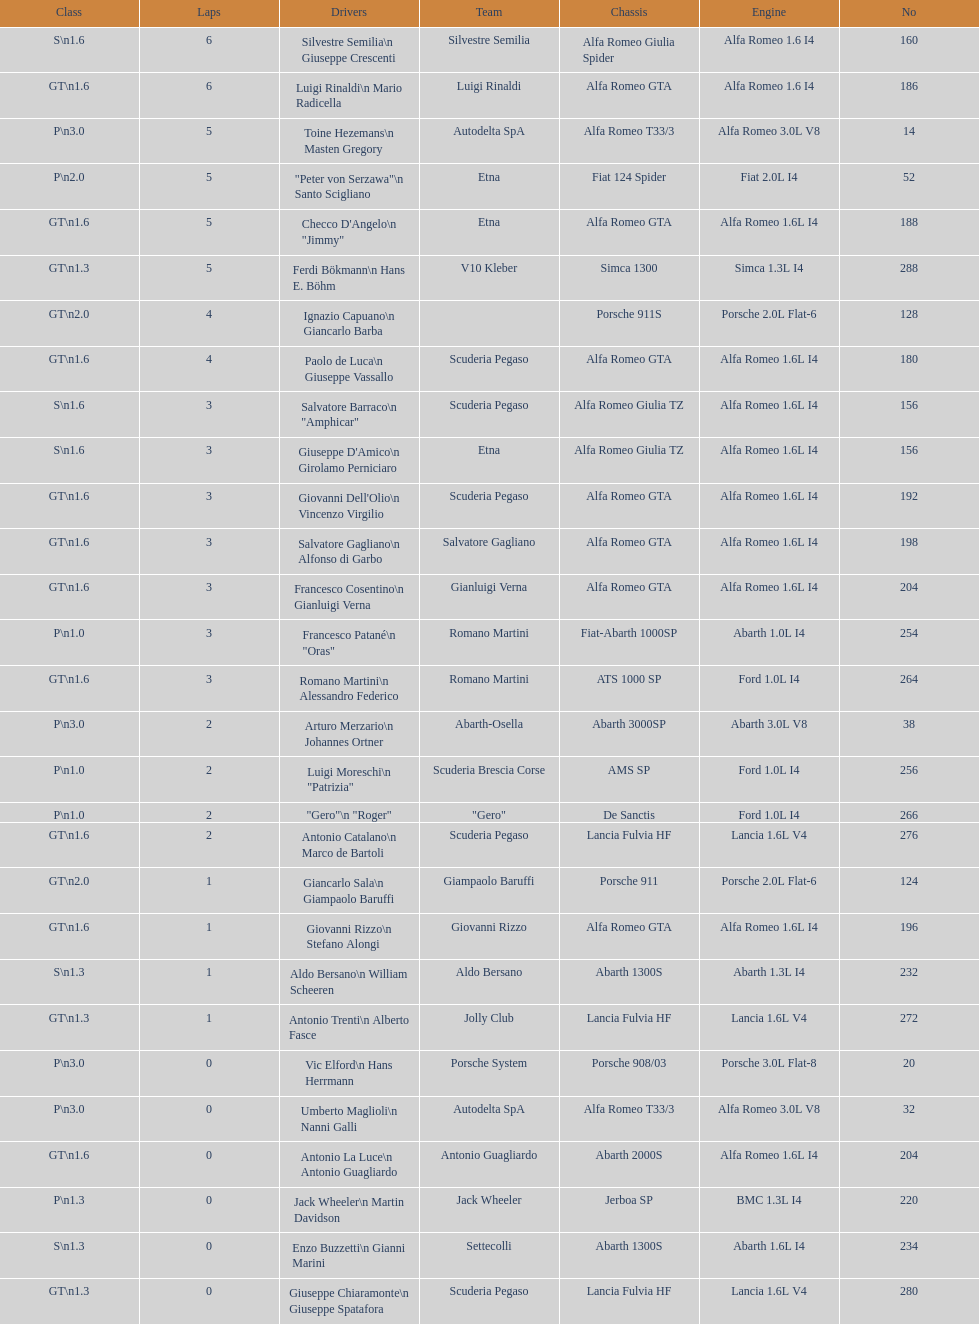His nickname is "jimmy," but what is his full name? Checco D'Angelo. 